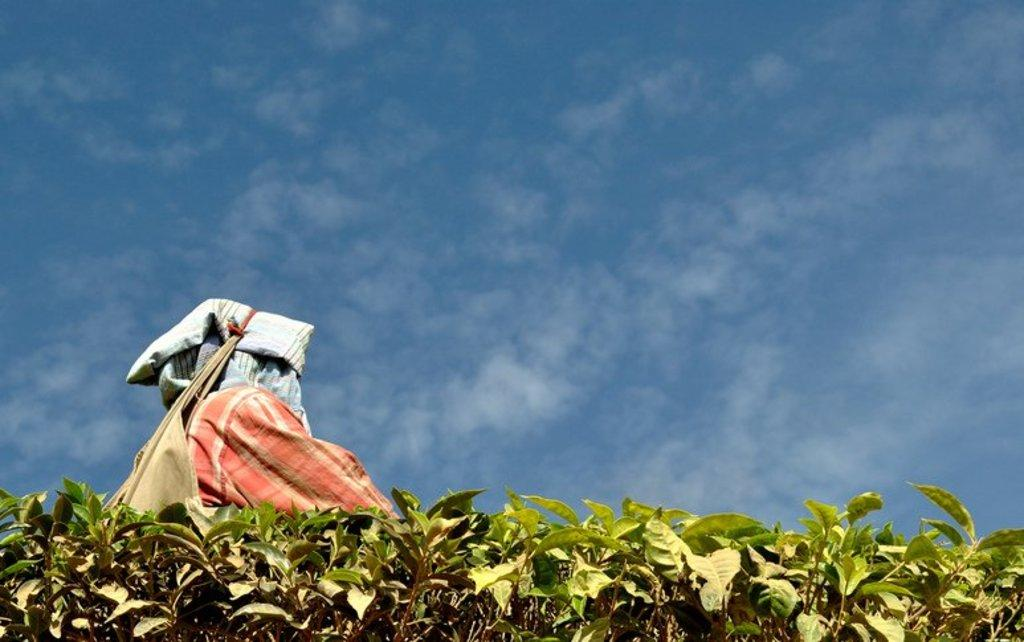What celestial bodies are depicted in the image? There are planets in the image. What else can be seen in the image besides the planets? There are clothes and other objects visible in the image. What is visible in the background of the image? The sky is visible in the background of the image. What type of comb can be seen in the image? There is no comb present in the image. Can you tell me how many bones are visible in the image? There are no bones visible in the image. 